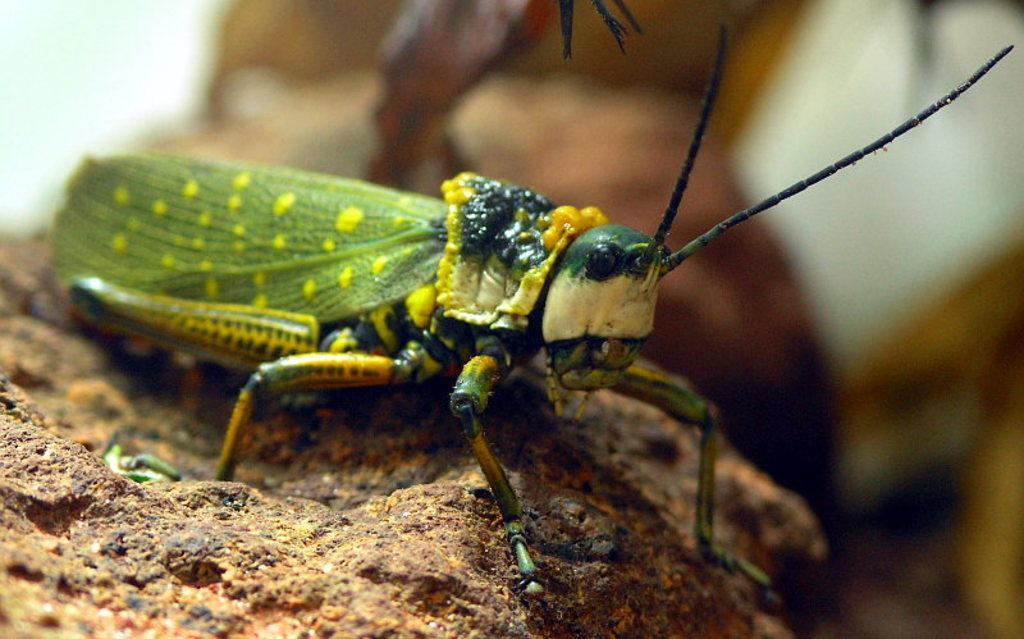Describe this image in one or two sentences. In this image we can see an insect on a stone. In the background it is blur. 